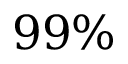<formula> <loc_0><loc_0><loc_500><loc_500>9 9 \%</formula> 